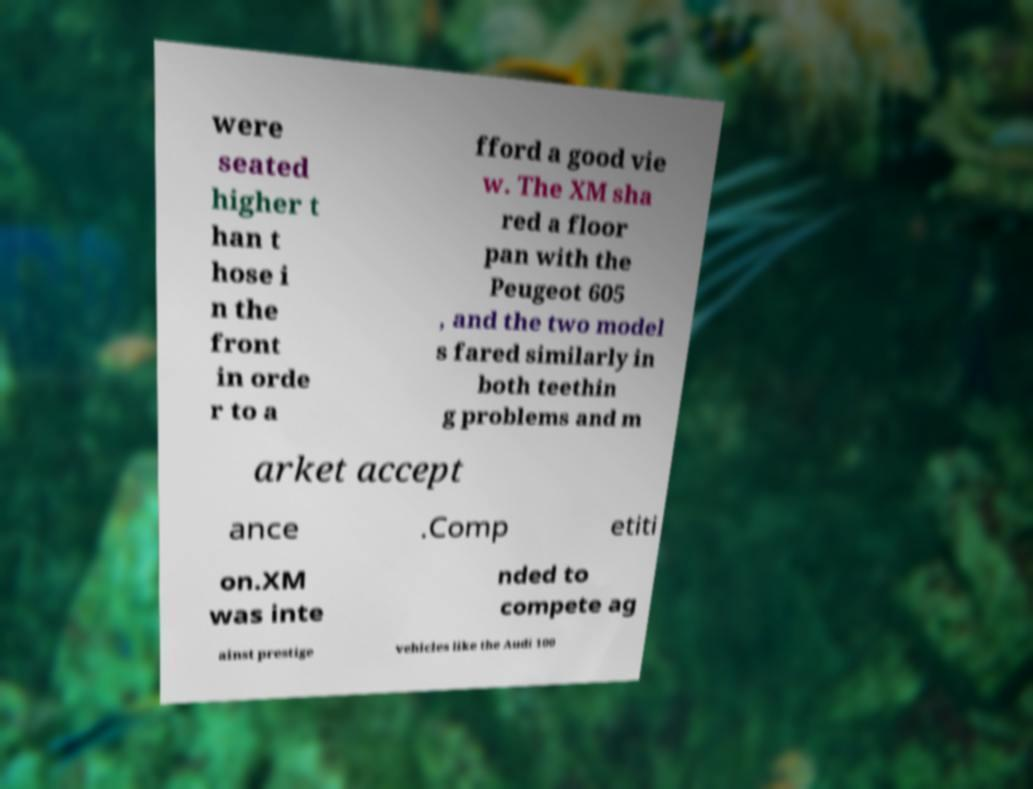For documentation purposes, I need the text within this image transcribed. Could you provide that? were seated higher t han t hose i n the front in orde r to a fford a good vie w. The XM sha red a floor pan with the Peugeot 605 , and the two model s fared similarly in both teethin g problems and m arket accept ance .Comp etiti on.XM was inte nded to compete ag ainst prestige vehicles like the Audi 100 